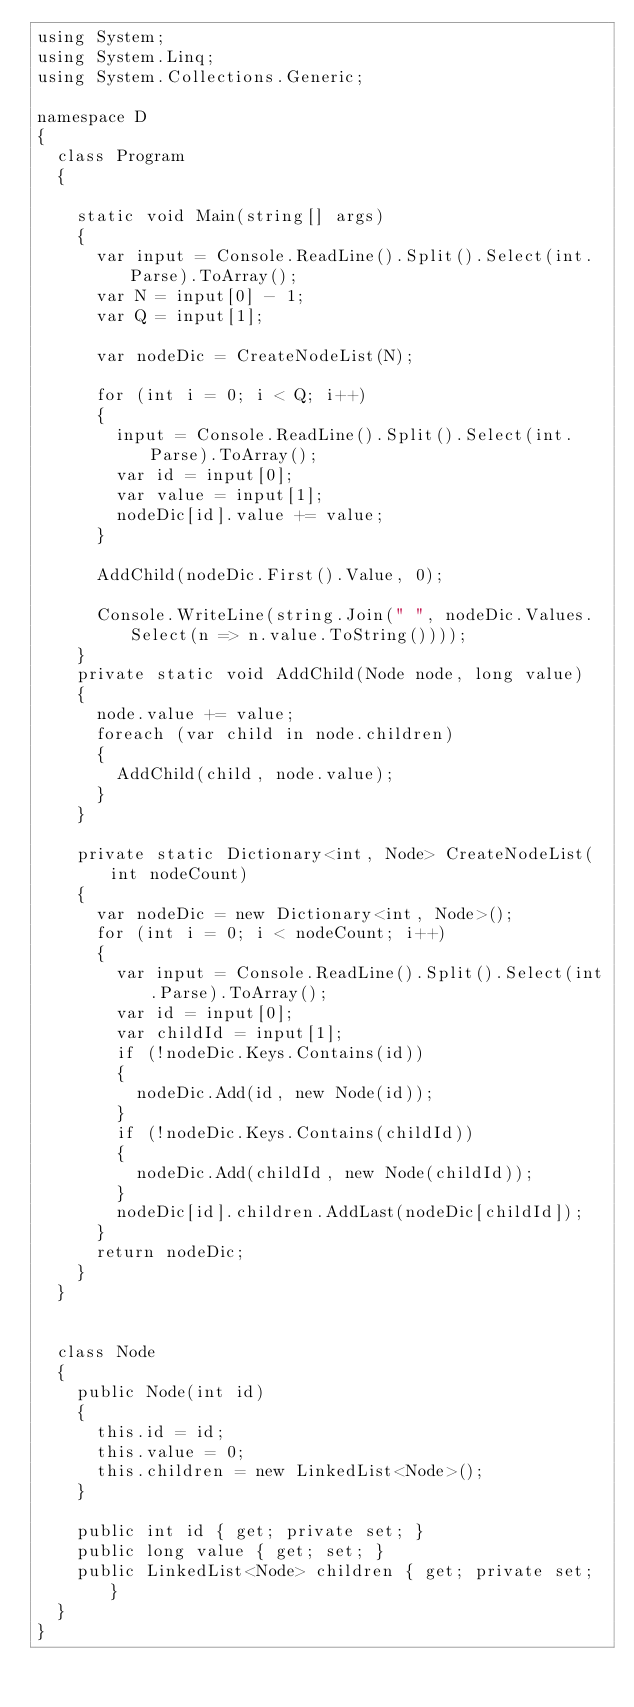Convert code to text. <code><loc_0><loc_0><loc_500><loc_500><_C#_>using System;
using System.Linq;
using System.Collections.Generic;

namespace D
{
  class Program
  {

    static void Main(string[] args)
    {
      var input = Console.ReadLine().Split().Select(int.Parse).ToArray();
      var N = input[0] - 1;
      var Q = input[1];

      var nodeDic = CreateNodeList(N);

      for (int i = 0; i < Q; i++)
      {
        input = Console.ReadLine().Split().Select(int.Parse).ToArray();
        var id = input[0];
        var value = input[1];
        nodeDic[id].value += value;
      }

      AddChild(nodeDic.First().Value, 0);

      Console.WriteLine(string.Join(" ", nodeDic.Values.Select(n => n.value.ToString())));
    }
    private static void AddChild(Node node, long value)
    {
      node.value += value;
      foreach (var child in node.children)
      {
        AddChild(child, node.value);
      }
    }

    private static Dictionary<int, Node> CreateNodeList(int nodeCount)
    {
      var nodeDic = new Dictionary<int, Node>();
      for (int i = 0; i < nodeCount; i++)
      {
        var input = Console.ReadLine().Split().Select(int.Parse).ToArray();
        var id = input[0];
        var childId = input[1];
        if (!nodeDic.Keys.Contains(id))
        {
          nodeDic.Add(id, new Node(id));
        }
        if (!nodeDic.Keys.Contains(childId))
        {
          nodeDic.Add(childId, new Node(childId));
        }
        nodeDic[id].children.AddLast(nodeDic[childId]);
      }
      return nodeDic;
    }
  }


  class Node
  {
    public Node(int id)
    {
      this.id = id;
      this.value = 0;
      this.children = new LinkedList<Node>();
    }

    public int id { get; private set; }
    public long value { get; set; }
    public LinkedList<Node> children { get; private set; }
  }
}
</code> 